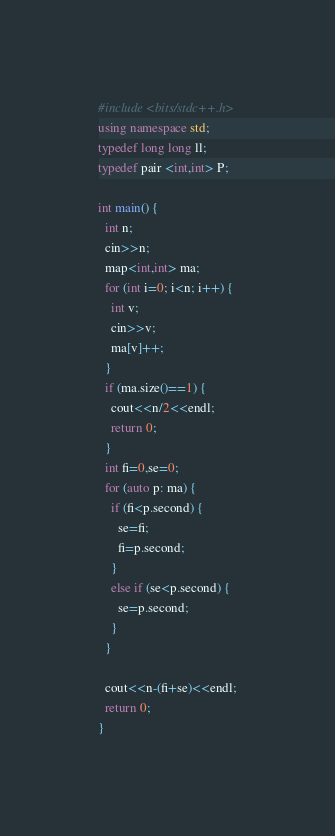Convert code to text. <code><loc_0><loc_0><loc_500><loc_500><_C++_>#include <bits/stdc++.h>
using namespace std;
typedef long long ll;
typedef pair <int,int> P;

int main() {
  int n;
  cin>>n;
  map<int,int> ma;
  for (int i=0; i<n; i++) {
    int v;
    cin>>v;
    ma[v]++;
  }
  if (ma.size()==1) {
    cout<<n/2<<endl;
    return 0;
  }
  int fi=0,se=0;
  for (auto p: ma) {
    if (fi<p.second) {
      se=fi;
      fi=p.second;
    }
    else if (se<p.second) {
      se=p.second;
    }
  }
      
  cout<<n-(fi+se)<<endl;
  return 0;
}</code> 